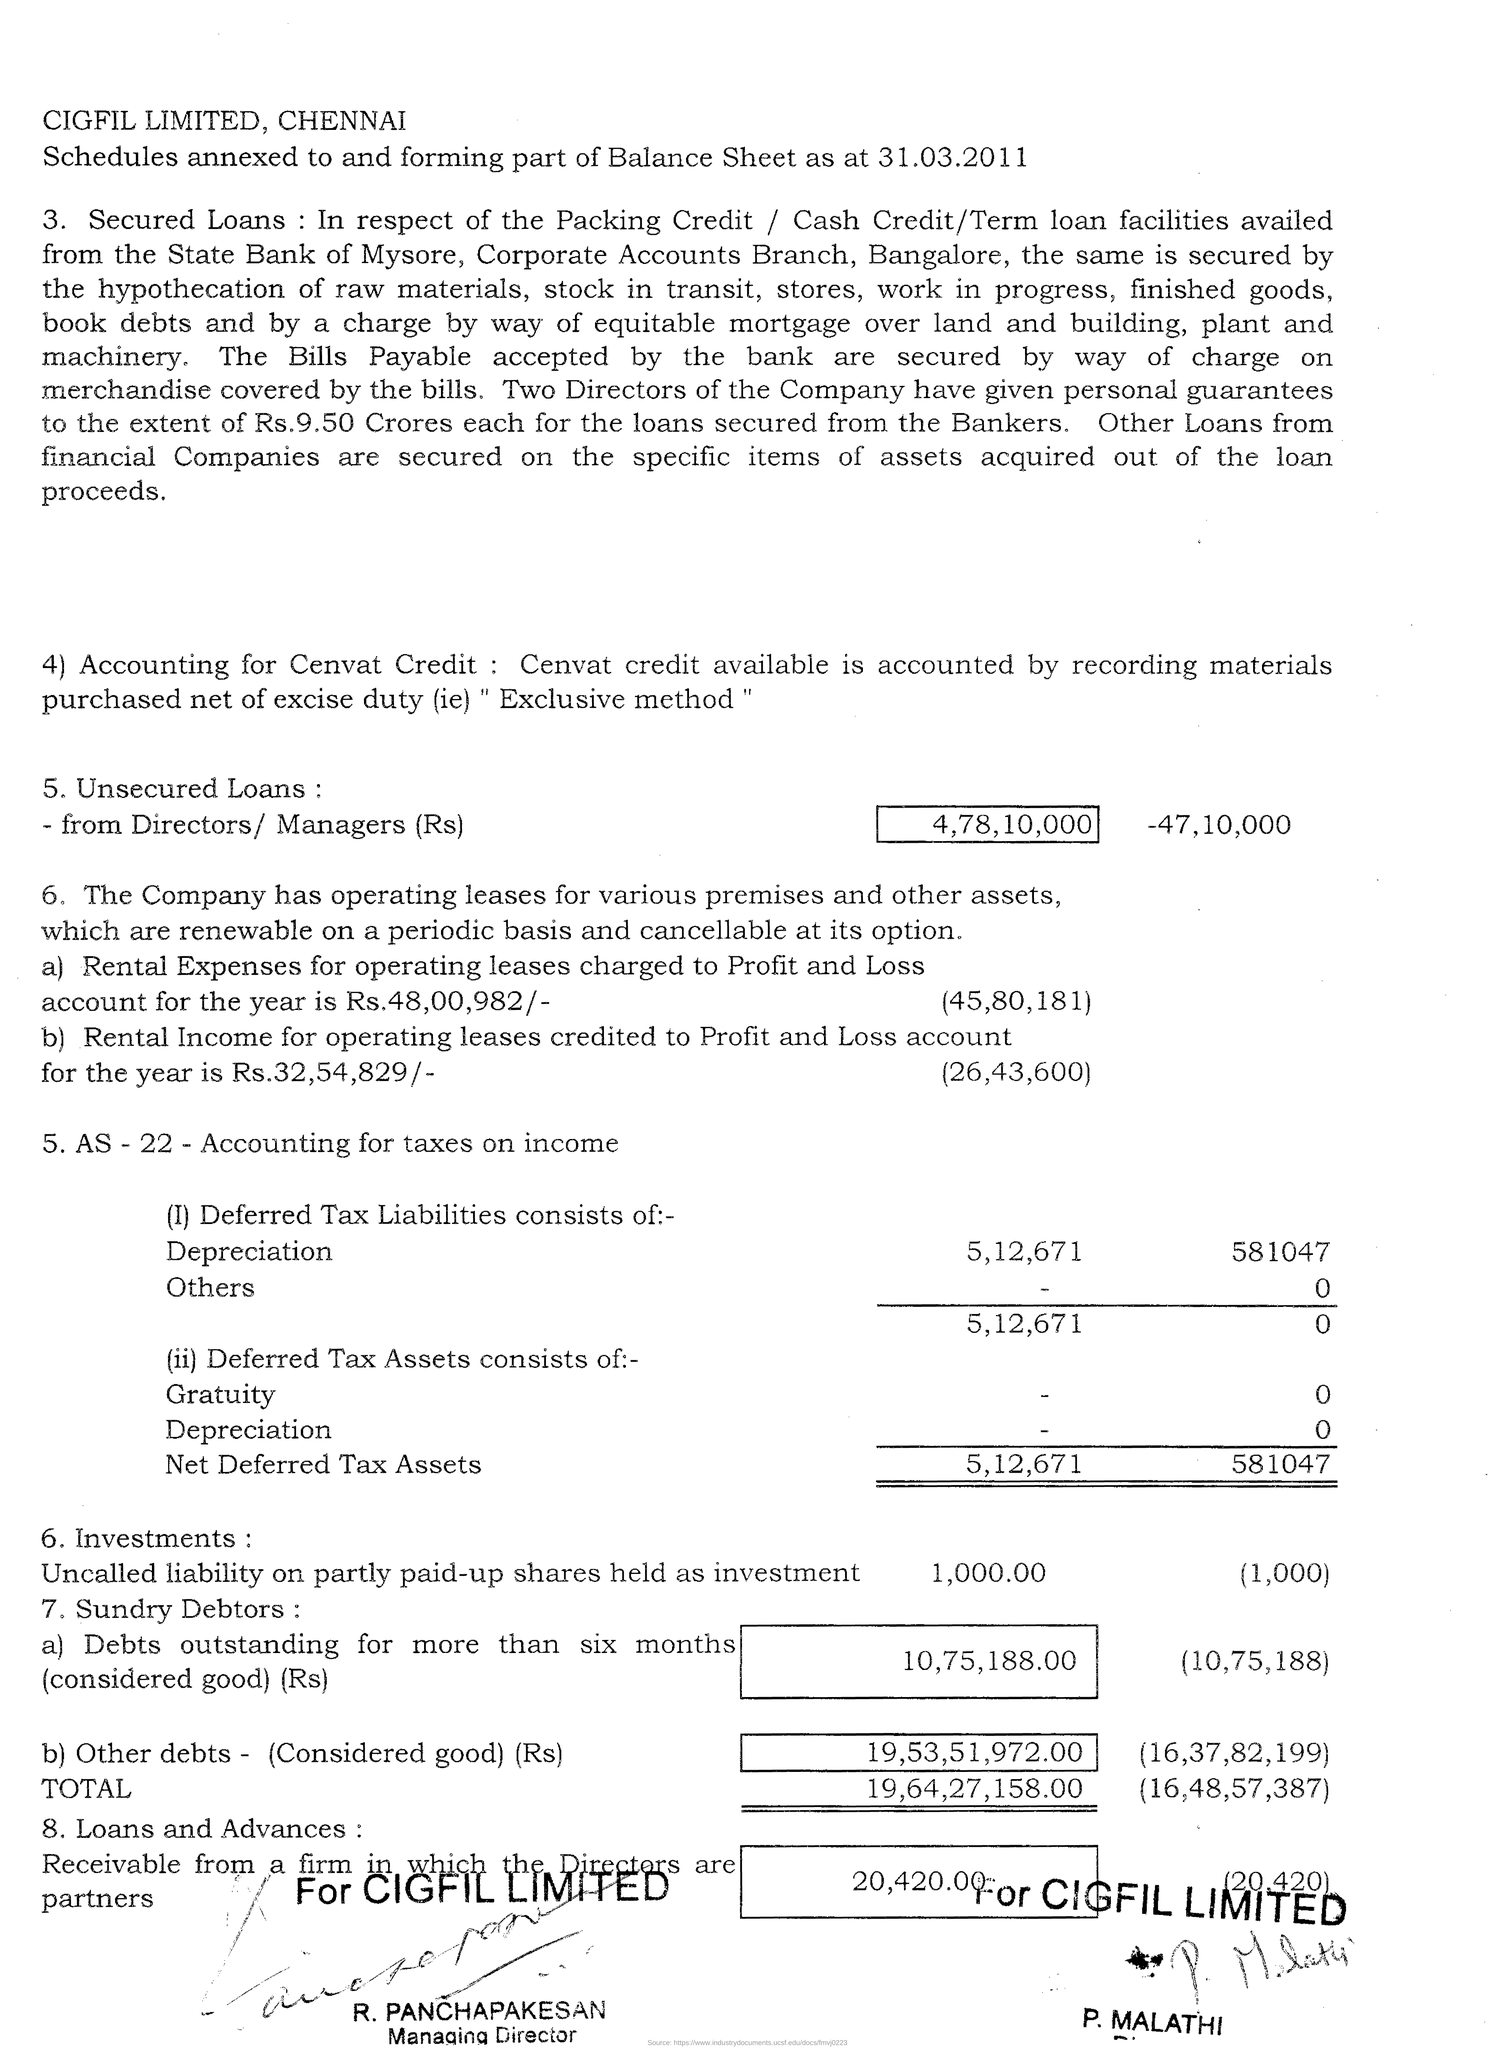Give some essential details in this illustration. CIGFIL Limited is located in Chennai. The exclusive method is used for availing Cenvat credit. 